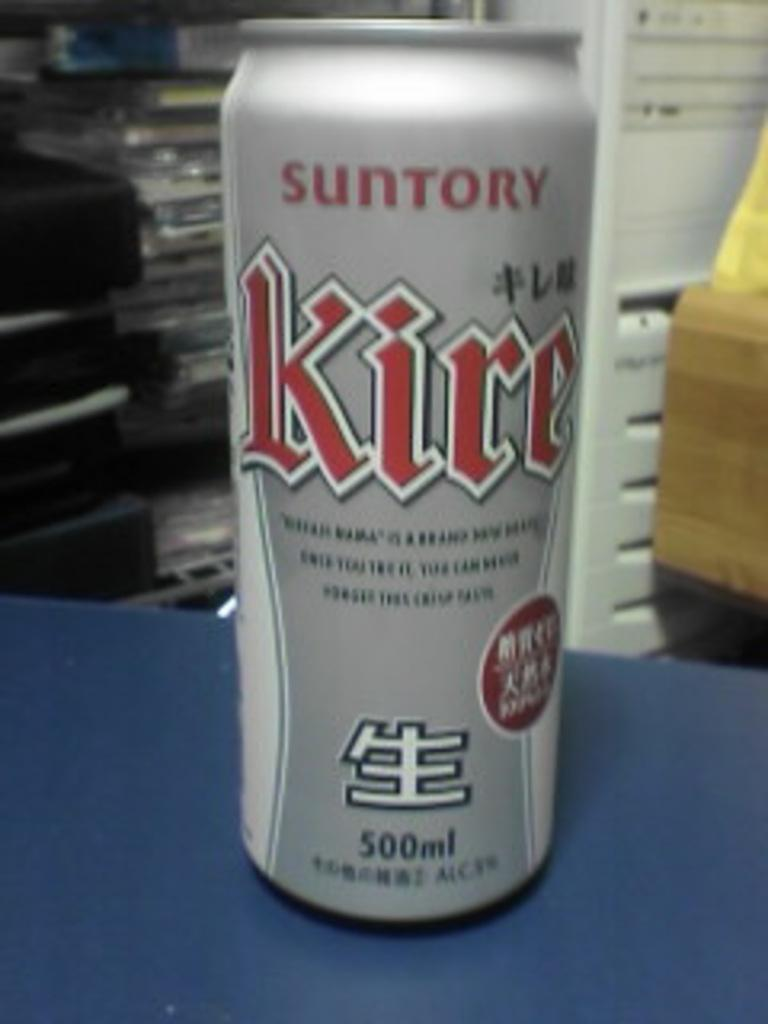<image>
Share a concise interpretation of the image provided. A 500 ml can of a beverage called Suntory. 